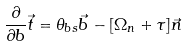Convert formula to latex. <formula><loc_0><loc_0><loc_500><loc_500>\frac { \partial } { { \partial } b } \vec { t } = { \theta } _ { b s } \vec { b } - [ { \Omega } _ { n } + { \tau } ] \vec { n }</formula> 